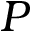Convert formula to latex. <formula><loc_0><loc_0><loc_500><loc_500>P</formula> 